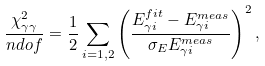Convert formula to latex. <formula><loc_0><loc_0><loc_500><loc_500>\frac { \chi ^ { 2 } _ { \gamma \gamma } } { n d o f } = \frac { 1 } { 2 } \sum _ { i = 1 , 2 } \left ( \frac { E _ { \gamma i } ^ { f i t } - E _ { \gamma i } ^ { m e a s } } { \sigma _ { E } E _ { \gamma i } ^ { m e a s } } \right ) ^ { 2 } ,</formula> 